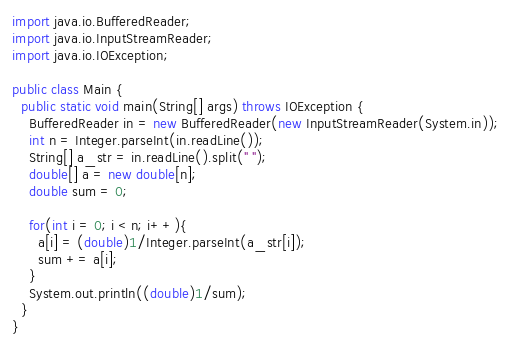Convert code to text. <code><loc_0><loc_0><loc_500><loc_500><_Java_>import java.io.BufferedReader;
import java.io.InputStreamReader;
import java.io.IOException;

public class Main {
  public static void main(String[] args) throws IOException {
    BufferedReader in = new BufferedReader(new InputStreamReader(System.in));
    int n = Integer.parseInt(in.readLine());
    String[] a_str = in.readLine().split(" ");
    double[] a = new double[n];
    double sum = 0;
    
    for(int i = 0; i < n; i++){
      a[i] = (double)1/Integer.parseInt(a_str[i]);
      sum += a[i];
    }
    System.out.println((double)1/sum);
  }
}</code> 